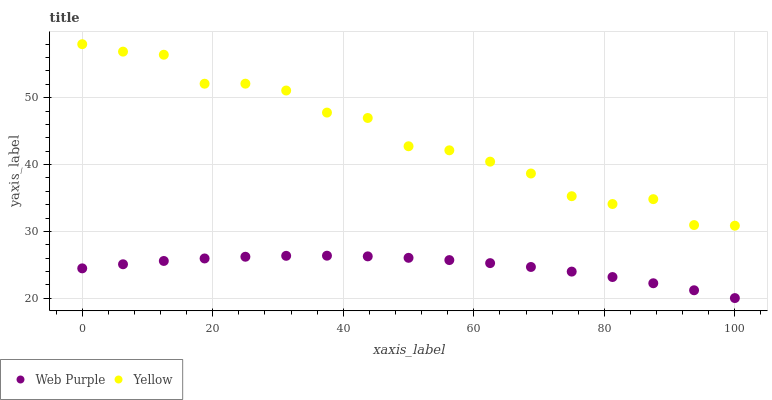Does Web Purple have the minimum area under the curve?
Answer yes or no. Yes. Does Yellow have the maximum area under the curve?
Answer yes or no. Yes. Does Yellow have the minimum area under the curve?
Answer yes or no. No. Is Web Purple the smoothest?
Answer yes or no. Yes. Is Yellow the roughest?
Answer yes or no. Yes. Is Yellow the smoothest?
Answer yes or no. No. Does Web Purple have the lowest value?
Answer yes or no. Yes. Does Yellow have the lowest value?
Answer yes or no. No. Does Yellow have the highest value?
Answer yes or no. Yes. Is Web Purple less than Yellow?
Answer yes or no. Yes. Is Yellow greater than Web Purple?
Answer yes or no. Yes. Does Web Purple intersect Yellow?
Answer yes or no. No. 